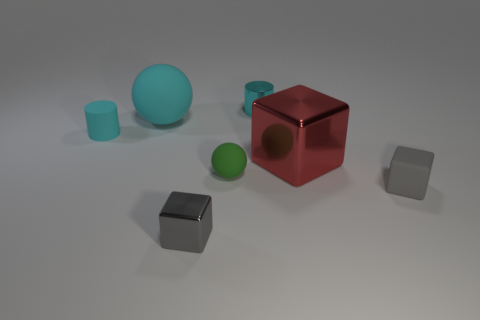Subtract all small gray cubes. How many cubes are left? 1 Add 2 tiny green spheres. How many objects exist? 9 Add 4 large red shiny cubes. How many large red shiny cubes are left? 5 Add 3 small gray metal things. How many small gray metal things exist? 4 Subtract all green spheres. How many spheres are left? 1 Subtract 0 green cylinders. How many objects are left? 7 Subtract all balls. How many objects are left? 5 Subtract 1 cylinders. How many cylinders are left? 1 Subtract all purple blocks. Subtract all yellow cylinders. How many blocks are left? 3 Subtract all brown blocks. How many green balls are left? 1 